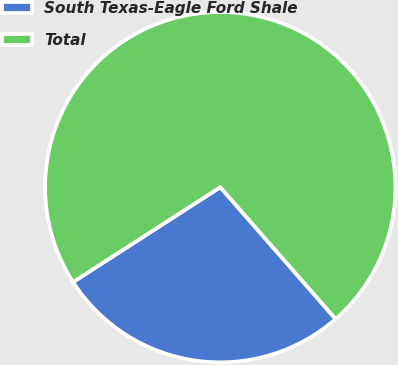<chart> <loc_0><loc_0><loc_500><loc_500><pie_chart><fcel>South Texas-Eagle Ford Shale<fcel>Total<nl><fcel>27.33%<fcel>72.67%<nl></chart> 